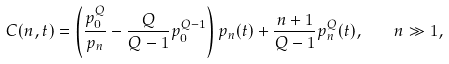<formula> <loc_0><loc_0><loc_500><loc_500>C ( n , t ) = \left ( \frac { p _ { 0 } ^ { Q } } { p _ { n } } - \frac { Q } { Q - 1 } p _ { 0 } ^ { Q - 1 } \right ) p _ { n } ( t ) + \frac { n + 1 } { Q - 1 } p _ { n } ^ { Q } ( t ) , \quad n \gg 1 ,</formula> 